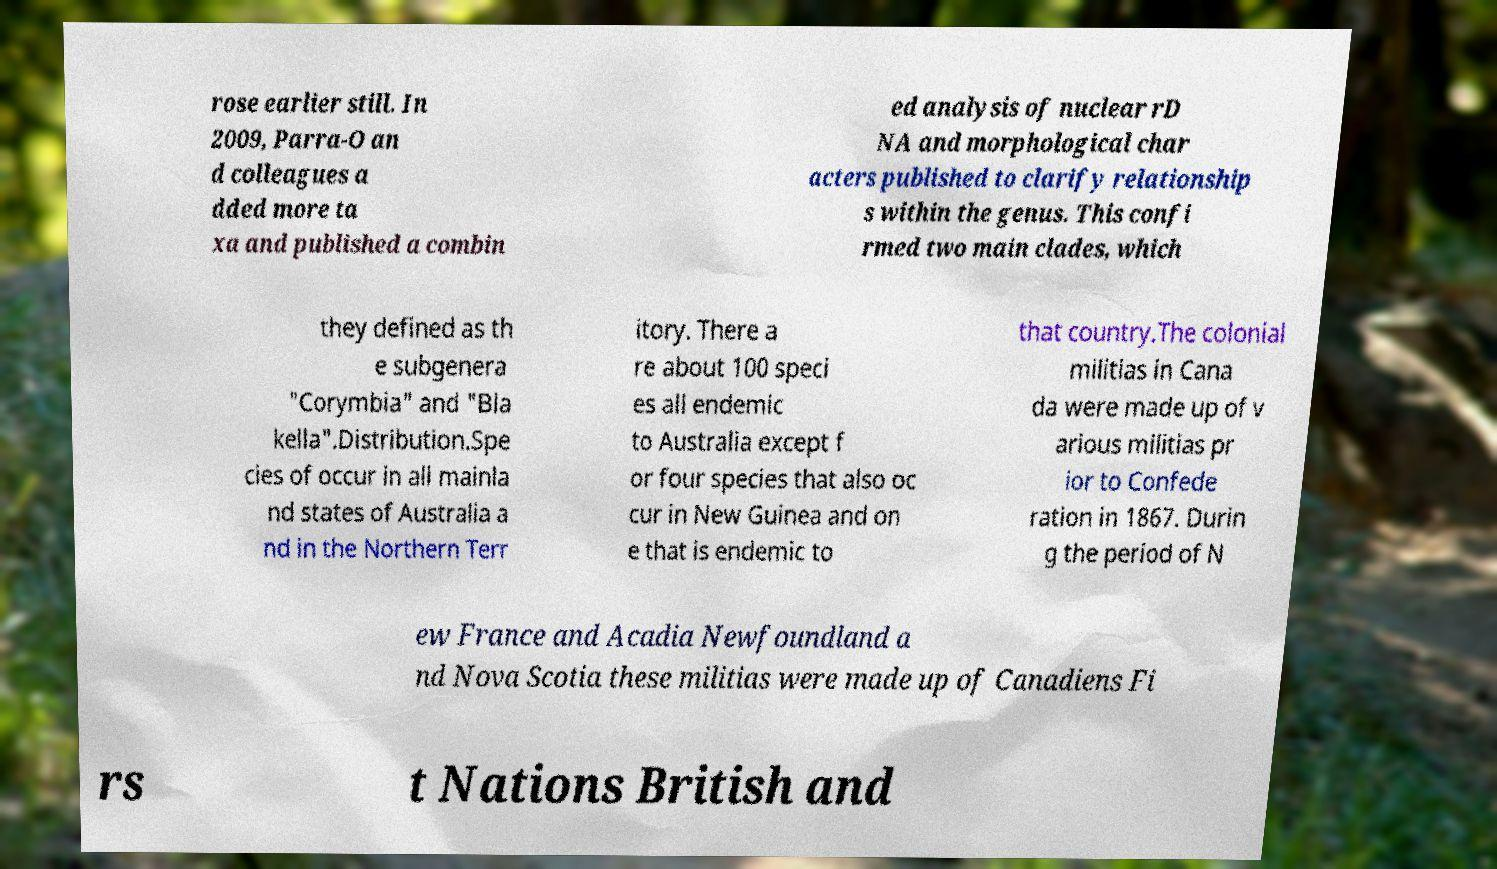For documentation purposes, I need the text within this image transcribed. Could you provide that? rose earlier still. In 2009, Parra-O an d colleagues a dded more ta xa and published a combin ed analysis of nuclear rD NA and morphological char acters published to clarify relationship s within the genus. This confi rmed two main clades, which they defined as th e subgenera "Corymbia" and "Bla kella".Distribution.Spe cies of occur in all mainla nd states of Australia a nd in the Northern Terr itory. There a re about 100 speci es all endemic to Australia except f or four species that also oc cur in New Guinea and on e that is endemic to that country.The colonial militias in Cana da were made up of v arious militias pr ior to Confede ration in 1867. Durin g the period of N ew France and Acadia Newfoundland a nd Nova Scotia these militias were made up of Canadiens Fi rs t Nations British and 